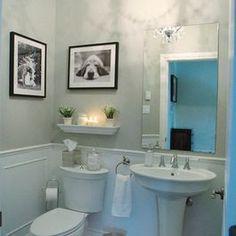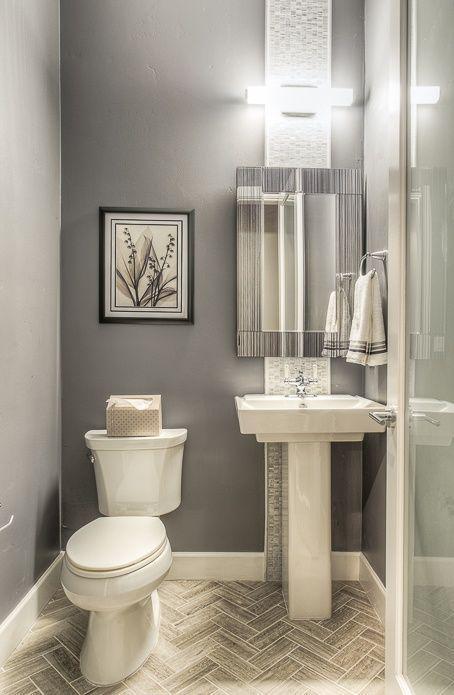The first image is the image on the left, the second image is the image on the right. Evaluate the accuracy of this statement regarding the images: "One bathroom features a rectangular mirror over a pedestal sink with a flower in a vase on it, and the other image shows a sink with a box-shaped vanity and a non-square mirror.". Is it true? Answer yes or no. No. The first image is the image on the left, the second image is the image on the right. Analyze the images presented: Is the assertion "One of the images features a sink with a cabinet underneath." valid? Answer yes or no. No. 